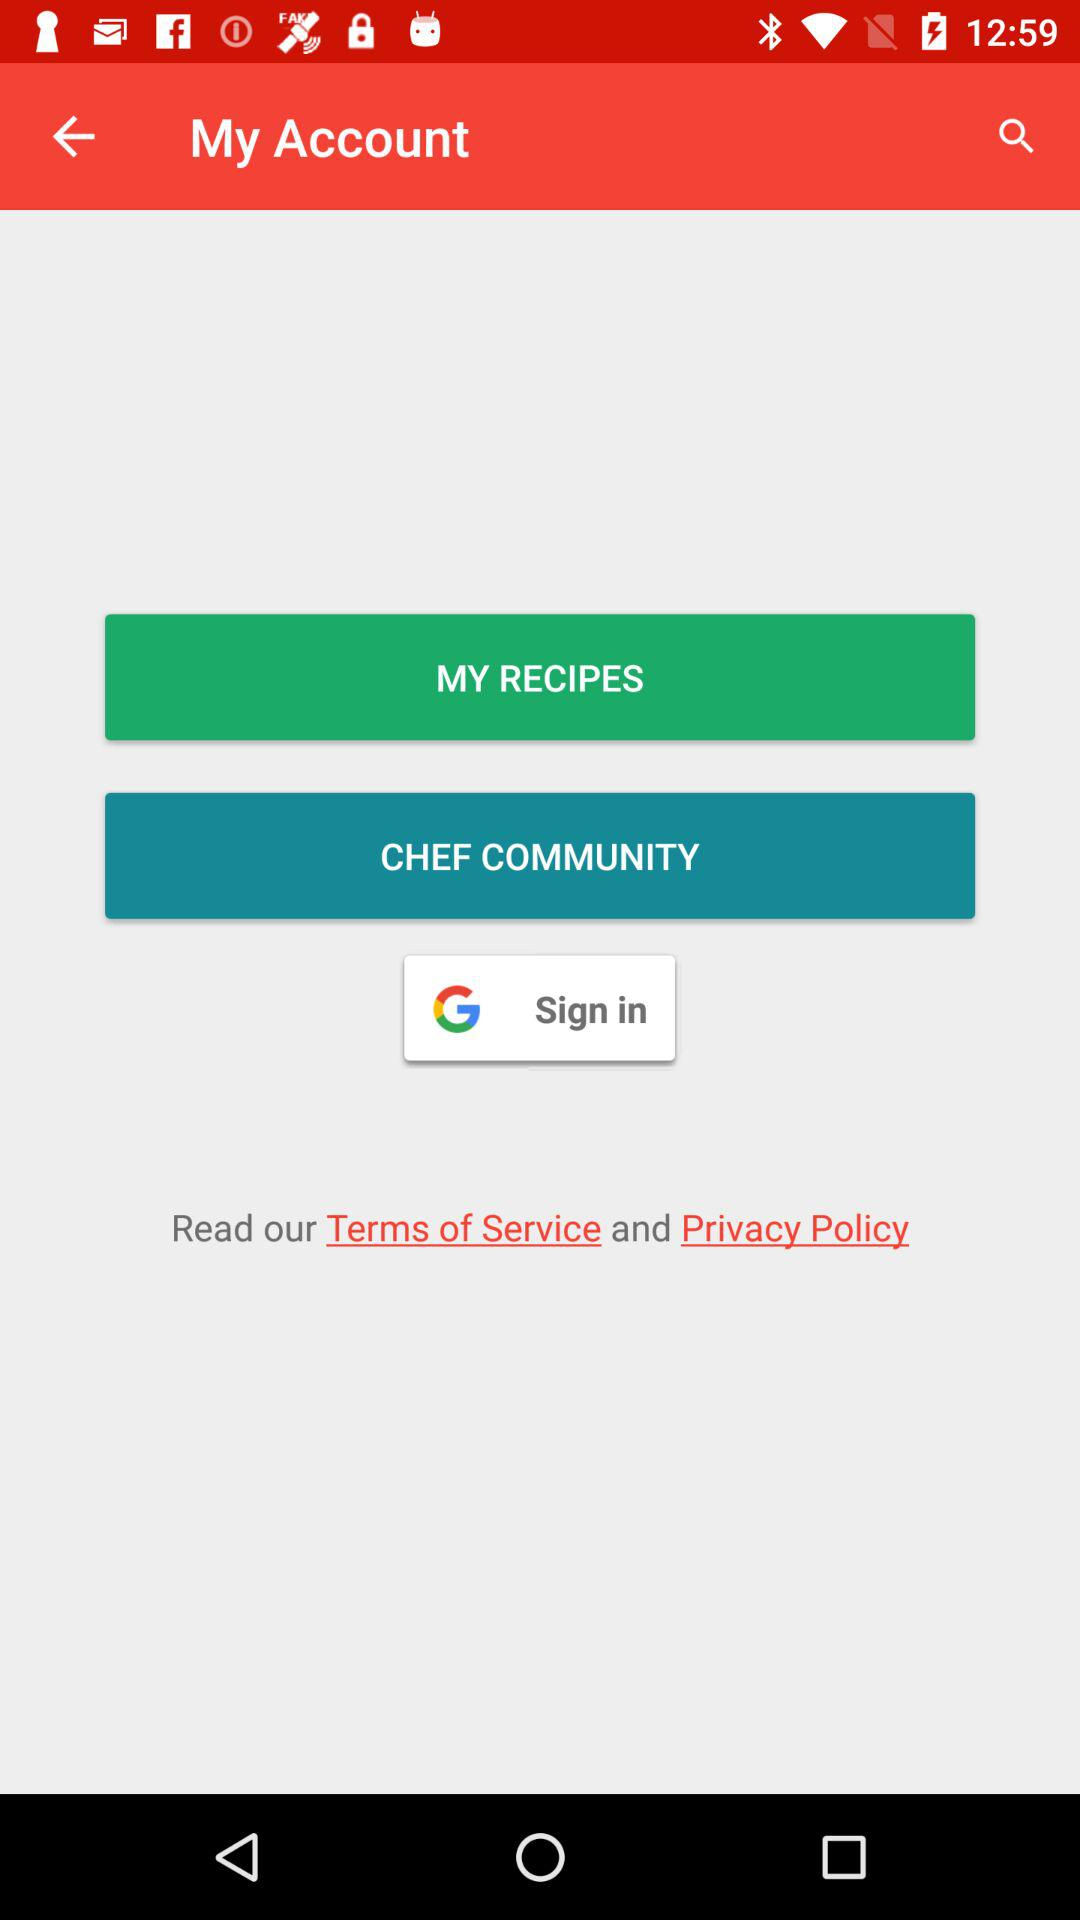Where can i sign in?
When the provided information is insufficient, respond with <no answer>. <no answer> 